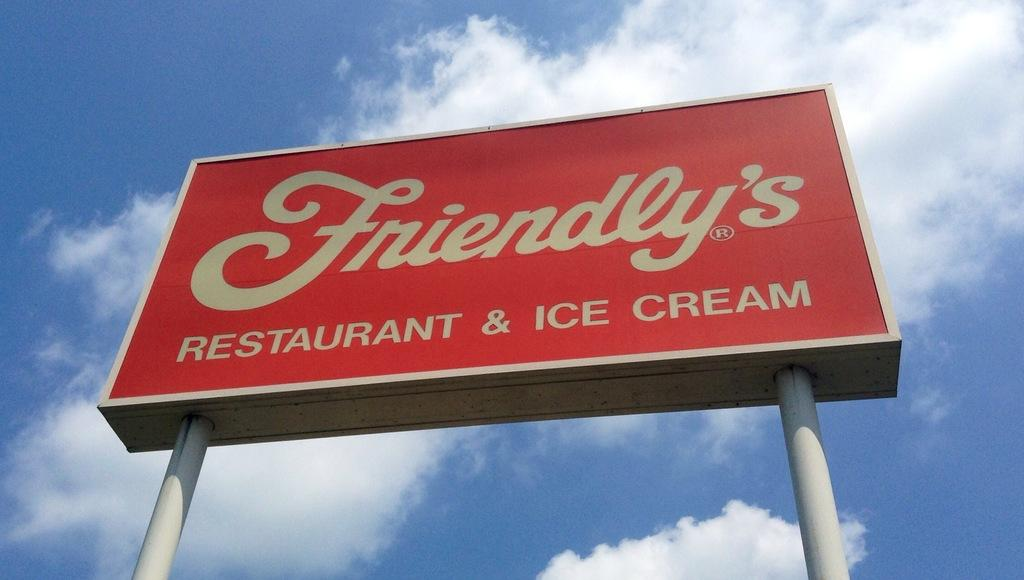<image>
Write a terse but informative summary of the picture. a sign for Friendly's advertising its restaurant and ice cream. 